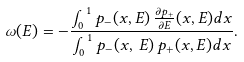Convert formula to latex. <formula><loc_0><loc_0><loc_500><loc_500>\omega ( E ) = - \frac { \int _ { 0 } ^ { 1 } p _ { - } ( x , E ) \, \frac { \partial p _ { + } } { \partial E } ( x , E ) d x } { \int _ { 0 } ^ { 1 } p _ { - } ( x , \, E ) \, p _ { + } ( x , E ) d x } .</formula> 